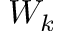<formula> <loc_0><loc_0><loc_500><loc_500>W _ { k }</formula> 